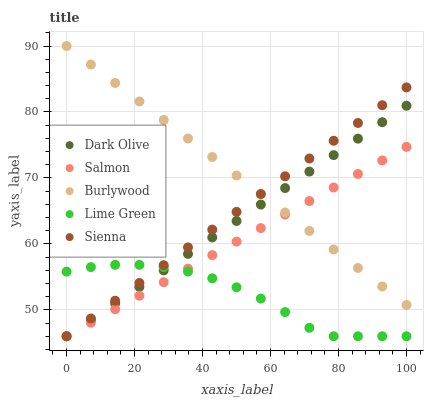Does Lime Green have the minimum area under the curve?
Answer yes or no. Yes. Does Burlywood have the maximum area under the curve?
Answer yes or no. Yes. Does Dark Olive have the minimum area under the curve?
Answer yes or no. No. Does Dark Olive have the maximum area under the curve?
Answer yes or no. No. Is Sienna the smoothest?
Answer yes or no. Yes. Is Lime Green the roughest?
Answer yes or no. Yes. Is Dark Olive the smoothest?
Answer yes or no. No. Is Dark Olive the roughest?
Answer yes or no. No. Does Lime Green have the lowest value?
Answer yes or no. Yes. Does Burlywood have the highest value?
Answer yes or no. Yes. Does Dark Olive have the highest value?
Answer yes or no. No. Is Lime Green less than Burlywood?
Answer yes or no. Yes. Is Burlywood greater than Lime Green?
Answer yes or no. Yes. Does Lime Green intersect Dark Olive?
Answer yes or no. Yes. Is Lime Green less than Dark Olive?
Answer yes or no. No. Is Lime Green greater than Dark Olive?
Answer yes or no. No. Does Lime Green intersect Burlywood?
Answer yes or no. No. 